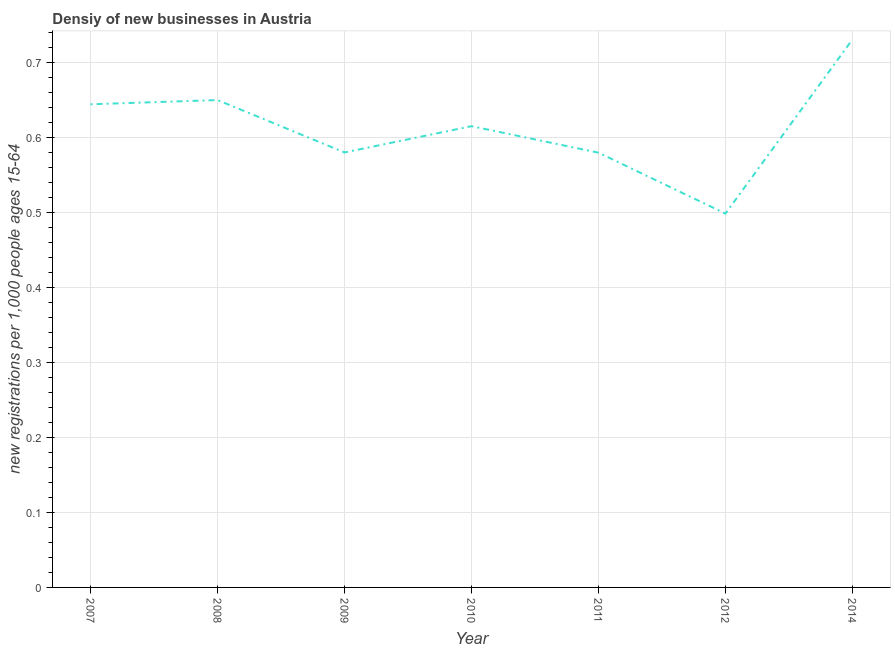What is the density of new business in 2014?
Provide a succinct answer. 0.73. Across all years, what is the maximum density of new business?
Make the answer very short. 0.73. Across all years, what is the minimum density of new business?
Your answer should be very brief. 0.5. What is the sum of the density of new business?
Provide a succinct answer. 4.29. What is the difference between the density of new business in 2009 and 2010?
Your answer should be very brief. -0.04. What is the average density of new business per year?
Provide a short and direct response. 0.61. What is the median density of new business?
Make the answer very short. 0.61. Do a majority of the years between 2012 and 2007 (inclusive) have density of new business greater than 0.2 ?
Offer a very short reply. Yes. What is the ratio of the density of new business in 2009 to that in 2010?
Ensure brevity in your answer.  0.94. Is the density of new business in 2009 less than that in 2012?
Your response must be concise. No. What is the difference between the highest and the second highest density of new business?
Provide a succinct answer. 0.08. Is the sum of the density of new business in 2008 and 2011 greater than the maximum density of new business across all years?
Provide a short and direct response. Yes. What is the difference between the highest and the lowest density of new business?
Provide a short and direct response. 0.23. How many lines are there?
Your response must be concise. 1. How many years are there in the graph?
Give a very brief answer. 7. Does the graph contain any zero values?
Ensure brevity in your answer.  No. What is the title of the graph?
Your answer should be very brief. Densiy of new businesses in Austria. What is the label or title of the X-axis?
Provide a succinct answer. Year. What is the label or title of the Y-axis?
Your answer should be very brief. New registrations per 1,0 people ages 15-64. What is the new registrations per 1,000 people ages 15-64 in 2007?
Give a very brief answer. 0.64. What is the new registrations per 1,000 people ages 15-64 of 2008?
Your response must be concise. 0.65. What is the new registrations per 1,000 people ages 15-64 of 2009?
Your response must be concise. 0.58. What is the new registrations per 1,000 people ages 15-64 in 2010?
Your answer should be compact. 0.61. What is the new registrations per 1,000 people ages 15-64 of 2011?
Keep it short and to the point. 0.58. What is the new registrations per 1,000 people ages 15-64 of 2012?
Offer a terse response. 0.5. What is the new registrations per 1,000 people ages 15-64 in 2014?
Provide a short and direct response. 0.73. What is the difference between the new registrations per 1,000 people ages 15-64 in 2007 and 2008?
Offer a very short reply. -0.01. What is the difference between the new registrations per 1,000 people ages 15-64 in 2007 and 2009?
Keep it short and to the point. 0.06. What is the difference between the new registrations per 1,000 people ages 15-64 in 2007 and 2010?
Keep it short and to the point. 0.03. What is the difference between the new registrations per 1,000 people ages 15-64 in 2007 and 2011?
Offer a terse response. 0.06. What is the difference between the new registrations per 1,000 people ages 15-64 in 2007 and 2012?
Provide a succinct answer. 0.15. What is the difference between the new registrations per 1,000 people ages 15-64 in 2007 and 2014?
Ensure brevity in your answer.  -0.09. What is the difference between the new registrations per 1,000 people ages 15-64 in 2008 and 2009?
Provide a short and direct response. 0.07. What is the difference between the new registrations per 1,000 people ages 15-64 in 2008 and 2010?
Give a very brief answer. 0.03. What is the difference between the new registrations per 1,000 people ages 15-64 in 2008 and 2011?
Keep it short and to the point. 0.07. What is the difference between the new registrations per 1,000 people ages 15-64 in 2008 and 2012?
Offer a very short reply. 0.15. What is the difference between the new registrations per 1,000 people ages 15-64 in 2008 and 2014?
Give a very brief answer. -0.08. What is the difference between the new registrations per 1,000 people ages 15-64 in 2009 and 2010?
Ensure brevity in your answer.  -0.04. What is the difference between the new registrations per 1,000 people ages 15-64 in 2009 and 2011?
Your response must be concise. 0. What is the difference between the new registrations per 1,000 people ages 15-64 in 2009 and 2012?
Give a very brief answer. 0.08. What is the difference between the new registrations per 1,000 people ages 15-64 in 2009 and 2014?
Your response must be concise. -0.15. What is the difference between the new registrations per 1,000 people ages 15-64 in 2010 and 2011?
Offer a terse response. 0.04. What is the difference between the new registrations per 1,000 people ages 15-64 in 2010 and 2012?
Provide a succinct answer. 0.12. What is the difference between the new registrations per 1,000 people ages 15-64 in 2010 and 2014?
Ensure brevity in your answer.  -0.12. What is the difference between the new registrations per 1,000 people ages 15-64 in 2011 and 2012?
Offer a terse response. 0.08. What is the difference between the new registrations per 1,000 people ages 15-64 in 2011 and 2014?
Give a very brief answer. -0.15. What is the difference between the new registrations per 1,000 people ages 15-64 in 2012 and 2014?
Keep it short and to the point. -0.23. What is the ratio of the new registrations per 1,000 people ages 15-64 in 2007 to that in 2009?
Your answer should be very brief. 1.11. What is the ratio of the new registrations per 1,000 people ages 15-64 in 2007 to that in 2010?
Provide a succinct answer. 1.05. What is the ratio of the new registrations per 1,000 people ages 15-64 in 2007 to that in 2011?
Give a very brief answer. 1.11. What is the ratio of the new registrations per 1,000 people ages 15-64 in 2007 to that in 2012?
Keep it short and to the point. 1.29. What is the ratio of the new registrations per 1,000 people ages 15-64 in 2007 to that in 2014?
Your answer should be compact. 0.88. What is the ratio of the new registrations per 1,000 people ages 15-64 in 2008 to that in 2009?
Your response must be concise. 1.12. What is the ratio of the new registrations per 1,000 people ages 15-64 in 2008 to that in 2010?
Your answer should be very brief. 1.06. What is the ratio of the new registrations per 1,000 people ages 15-64 in 2008 to that in 2011?
Provide a short and direct response. 1.12. What is the ratio of the new registrations per 1,000 people ages 15-64 in 2008 to that in 2012?
Offer a very short reply. 1.3. What is the ratio of the new registrations per 1,000 people ages 15-64 in 2008 to that in 2014?
Your answer should be very brief. 0.89. What is the ratio of the new registrations per 1,000 people ages 15-64 in 2009 to that in 2010?
Ensure brevity in your answer.  0.94. What is the ratio of the new registrations per 1,000 people ages 15-64 in 2009 to that in 2012?
Give a very brief answer. 1.16. What is the ratio of the new registrations per 1,000 people ages 15-64 in 2009 to that in 2014?
Your answer should be very brief. 0.79. What is the ratio of the new registrations per 1,000 people ages 15-64 in 2010 to that in 2011?
Offer a terse response. 1.06. What is the ratio of the new registrations per 1,000 people ages 15-64 in 2010 to that in 2012?
Keep it short and to the point. 1.23. What is the ratio of the new registrations per 1,000 people ages 15-64 in 2010 to that in 2014?
Provide a short and direct response. 0.84. What is the ratio of the new registrations per 1,000 people ages 15-64 in 2011 to that in 2012?
Keep it short and to the point. 1.16. What is the ratio of the new registrations per 1,000 people ages 15-64 in 2011 to that in 2014?
Your answer should be compact. 0.79. What is the ratio of the new registrations per 1,000 people ages 15-64 in 2012 to that in 2014?
Provide a succinct answer. 0.68. 